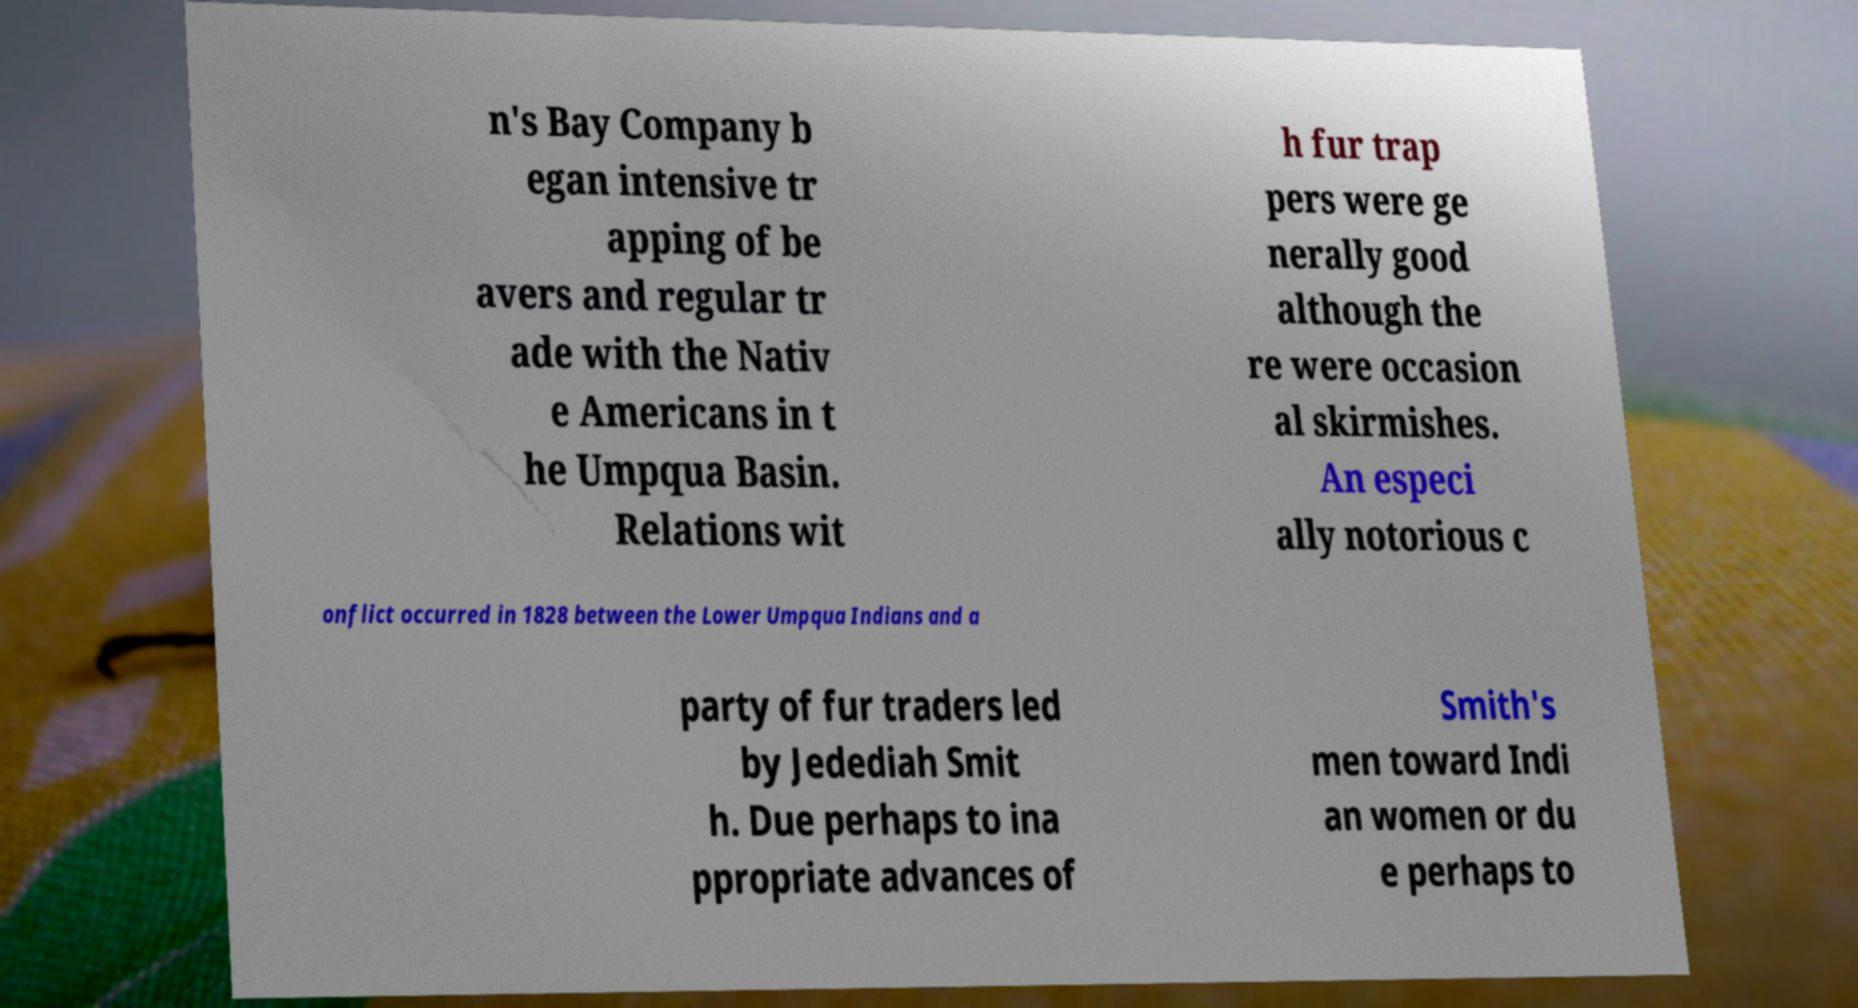Please identify and transcribe the text found in this image. n's Bay Company b egan intensive tr apping of be avers and regular tr ade with the Nativ e Americans in t he Umpqua Basin. Relations wit h fur trap pers were ge nerally good although the re were occasion al skirmishes. An especi ally notorious c onflict occurred in 1828 between the Lower Umpqua Indians and a party of fur traders led by Jedediah Smit h. Due perhaps to ina ppropriate advances of Smith's men toward Indi an women or du e perhaps to 